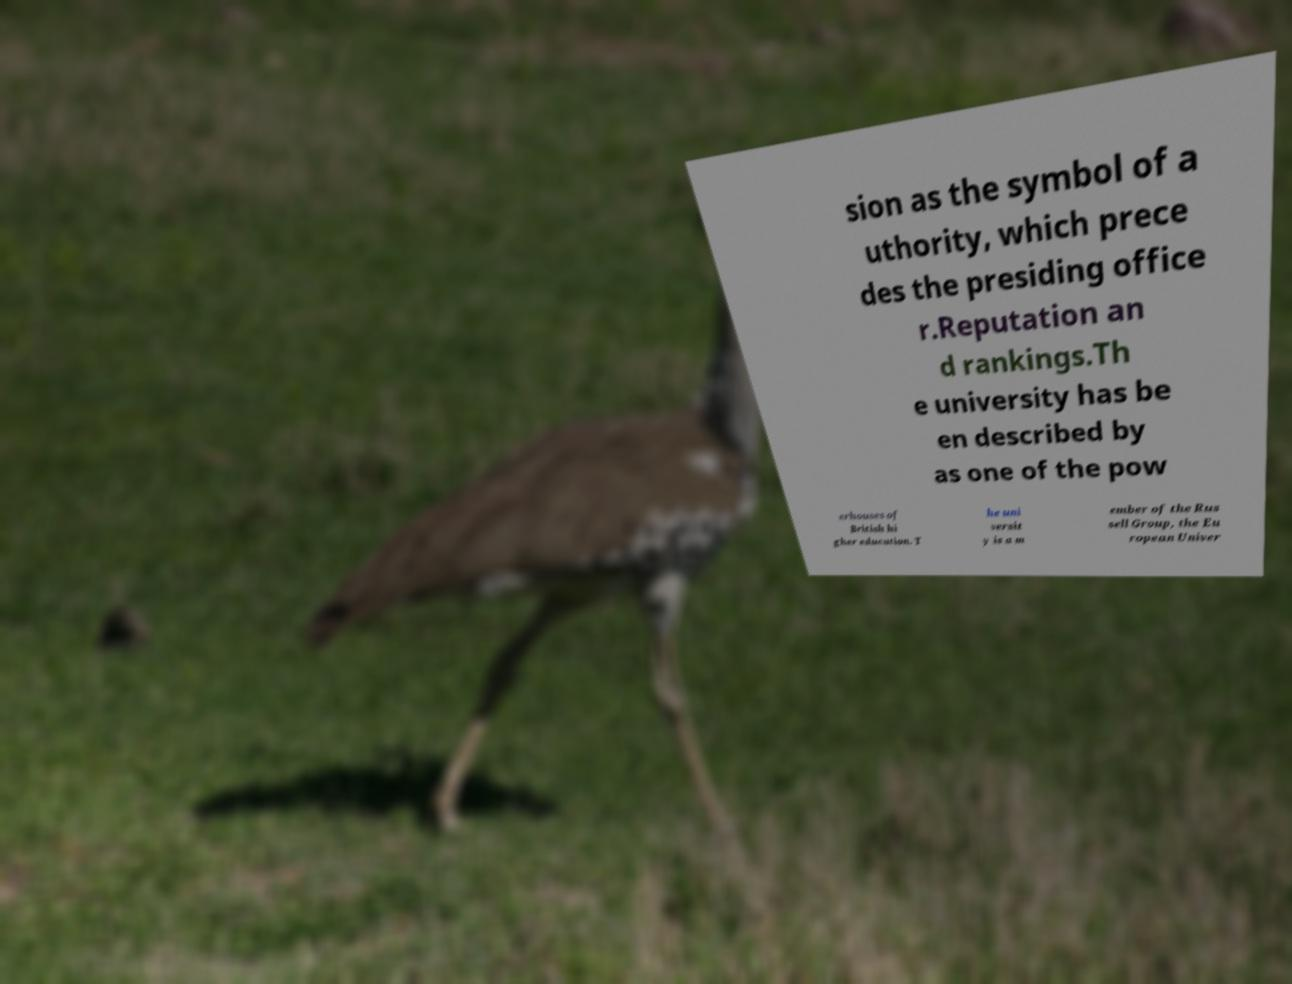I need the written content from this picture converted into text. Can you do that? sion as the symbol of a uthority, which prece des the presiding office r.Reputation an d rankings.Th e university has be en described by as one of the pow erhouses of British hi gher education. T he uni versit y is a m ember of the Rus sell Group, the Eu ropean Univer 